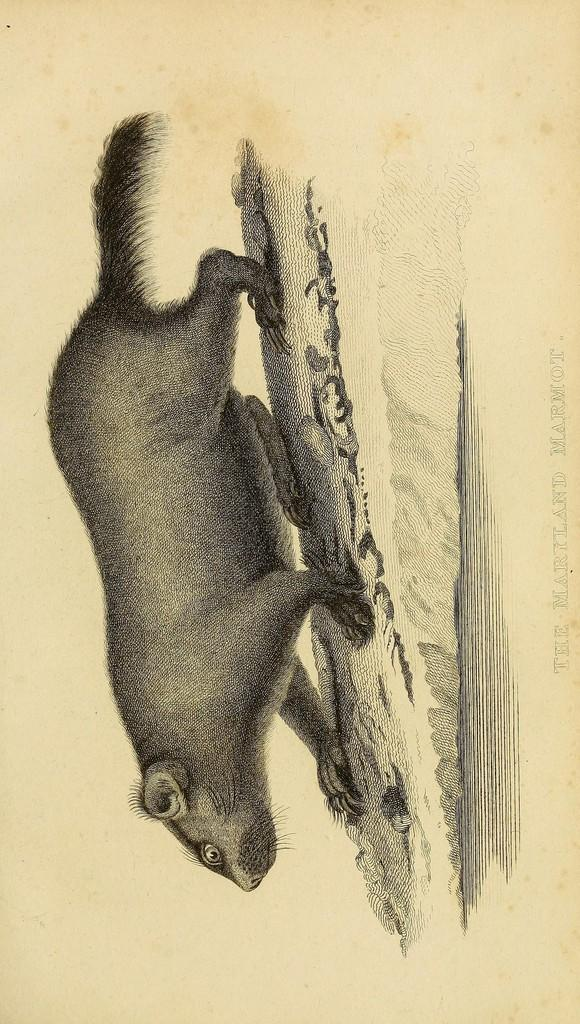What is depicted on the paper in the image? There is an art of an animal on the paper. What color is the art on the paper? The art is in black color. What is the color of the paper itself? The paper is in cream color. What type of wilderness can be seen in the background of the art? There is no background or wilderness visible in the image, as it only shows the art of an animal on a piece of paper. 